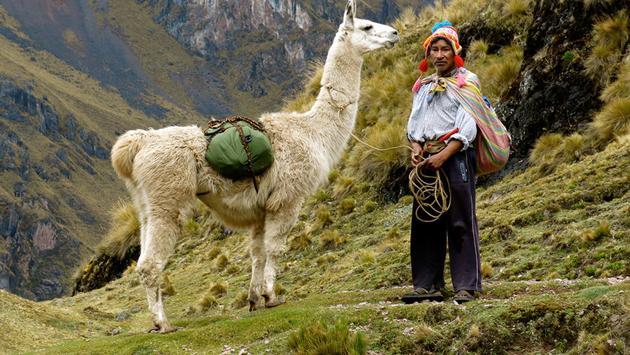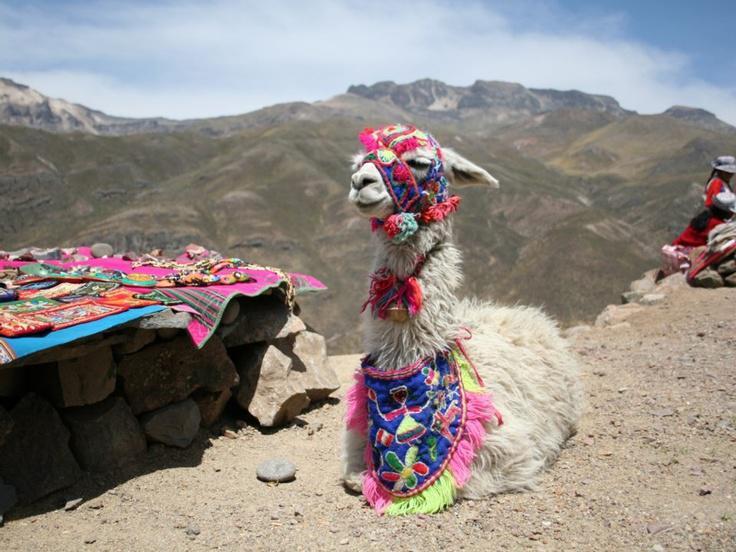The first image is the image on the left, the second image is the image on the right. For the images shown, is this caption "LLamas are showing off their colorful and festive attire." true? Answer yes or no. Yes. The first image is the image on the left, the second image is the image on the right. Considering the images on both sides, is "In one image there is a person standing next to a llama and in the other image there is a llama decorated with yarn." valid? Answer yes or no. Yes. 